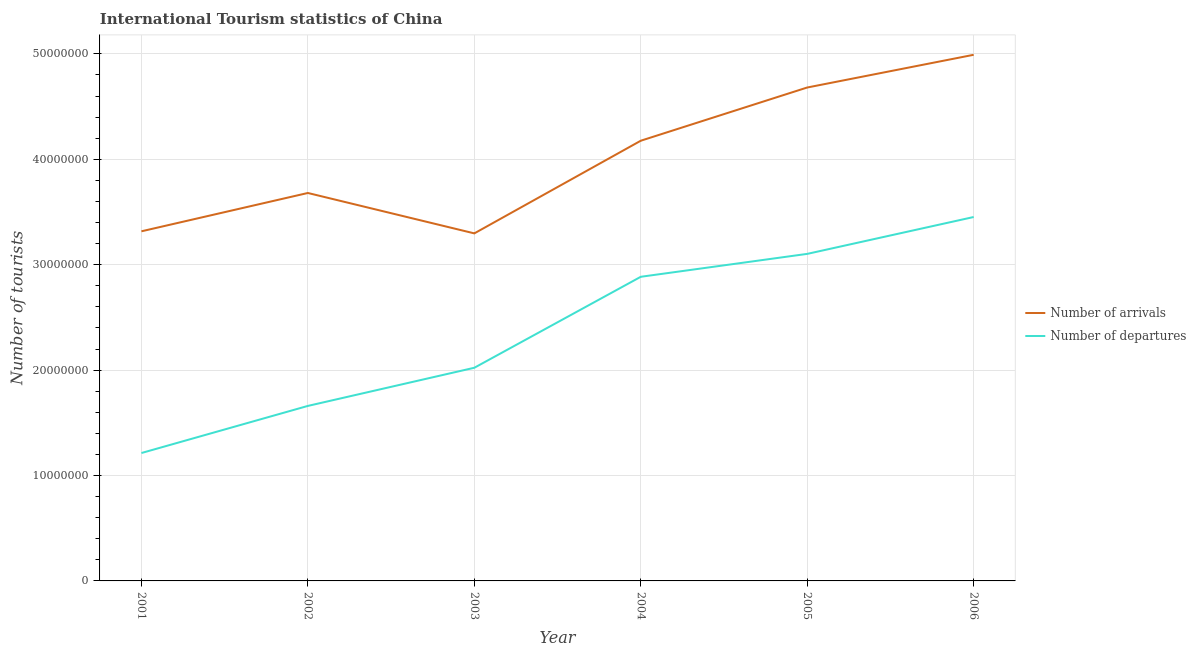How many different coloured lines are there?
Offer a very short reply. 2. Is the number of lines equal to the number of legend labels?
Your answer should be compact. Yes. What is the number of tourist departures in 2004?
Keep it short and to the point. 2.89e+07. Across all years, what is the maximum number of tourist departures?
Offer a terse response. 3.45e+07. Across all years, what is the minimum number of tourist arrivals?
Give a very brief answer. 3.30e+07. In which year was the number of tourist departures maximum?
Provide a succinct answer. 2006. What is the total number of tourist arrivals in the graph?
Keep it short and to the point. 2.41e+08. What is the difference between the number of tourist arrivals in 2004 and that in 2005?
Give a very brief answer. -5.05e+06. What is the difference between the number of tourist departures in 2003 and the number of tourist arrivals in 2004?
Your response must be concise. -2.15e+07. What is the average number of tourist arrivals per year?
Offer a very short reply. 4.02e+07. In the year 2005, what is the difference between the number of tourist departures and number of tourist arrivals?
Your response must be concise. -1.58e+07. In how many years, is the number of tourist arrivals greater than 46000000?
Give a very brief answer. 2. What is the ratio of the number of tourist departures in 2002 to that in 2006?
Your answer should be very brief. 0.48. Is the number of tourist departures in 2002 less than that in 2003?
Ensure brevity in your answer.  Yes. Is the difference between the number of tourist departures in 2003 and 2006 greater than the difference between the number of tourist arrivals in 2003 and 2006?
Make the answer very short. Yes. What is the difference between the highest and the second highest number of tourist departures?
Ensure brevity in your answer.  3.50e+06. What is the difference between the highest and the lowest number of tourist arrivals?
Your response must be concise. 1.69e+07. In how many years, is the number of tourist departures greater than the average number of tourist departures taken over all years?
Make the answer very short. 3. Is the sum of the number of tourist departures in 2002 and 2004 greater than the maximum number of tourist arrivals across all years?
Make the answer very short. No. Is the number of tourist arrivals strictly greater than the number of tourist departures over the years?
Your answer should be compact. Yes. What is the difference between two consecutive major ticks on the Y-axis?
Your answer should be very brief. 1.00e+07. Are the values on the major ticks of Y-axis written in scientific E-notation?
Your response must be concise. No. Does the graph contain grids?
Offer a very short reply. Yes. What is the title of the graph?
Provide a short and direct response. International Tourism statistics of China. Does "Private funds" appear as one of the legend labels in the graph?
Provide a succinct answer. No. What is the label or title of the Y-axis?
Offer a very short reply. Number of tourists. What is the Number of tourists of Number of arrivals in 2001?
Provide a succinct answer. 3.32e+07. What is the Number of tourists of Number of departures in 2001?
Offer a very short reply. 1.21e+07. What is the Number of tourists in Number of arrivals in 2002?
Your response must be concise. 3.68e+07. What is the Number of tourists in Number of departures in 2002?
Offer a very short reply. 1.66e+07. What is the Number of tourists of Number of arrivals in 2003?
Keep it short and to the point. 3.30e+07. What is the Number of tourists in Number of departures in 2003?
Offer a very short reply. 2.02e+07. What is the Number of tourists of Number of arrivals in 2004?
Your answer should be compact. 4.18e+07. What is the Number of tourists of Number of departures in 2004?
Offer a very short reply. 2.89e+07. What is the Number of tourists of Number of arrivals in 2005?
Offer a terse response. 4.68e+07. What is the Number of tourists of Number of departures in 2005?
Your answer should be very brief. 3.10e+07. What is the Number of tourists of Number of arrivals in 2006?
Your response must be concise. 4.99e+07. What is the Number of tourists of Number of departures in 2006?
Your response must be concise. 3.45e+07. Across all years, what is the maximum Number of tourists in Number of arrivals?
Offer a very short reply. 4.99e+07. Across all years, what is the maximum Number of tourists of Number of departures?
Your answer should be very brief. 3.45e+07. Across all years, what is the minimum Number of tourists of Number of arrivals?
Give a very brief answer. 3.30e+07. Across all years, what is the minimum Number of tourists of Number of departures?
Your answer should be compact. 1.21e+07. What is the total Number of tourists in Number of arrivals in the graph?
Your response must be concise. 2.41e+08. What is the total Number of tourists of Number of departures in the graph?
Offer a terse response. 1.43e+08. What is the difference between the Number of tourists of Number of arrivals in 2001 and that in 2002?
Provide a succinct answer. -3.64e+06. What is the difference between the Number of tourists in Number of departures in 2001 and that in 2002?
Your response must be concise. -4.47e+06. What is the difference between the Number of tourists in Number of arrivals in 2001 and that in 2003?
Keep it short and to the point. 1.97e+05. What is the difference between the Number of tourists of Number of departures in 2001 and that in 2003?
Your response must be concise. -8.09e+06. What is the difference between the Number of tourists of Number of arrivals in 2001 and that in 2004?
Keep it short and to the point. -8.59e+06. What is the difference between the Number of tourists of Number of departures in 2001 and that in 2004?
Your answer should be very brief. -1.67e+07. What is the difference between the Number of tourists in Number of arrivals in 2001 and that in 2005?
Offer a very short reply. -1.36e+07. What is the difference between the Number of tourists in Number of departures in 2001 and that in 2005?
Your answer should be very brief. -1.89e+07. What is the difference between the Number of tourists in Number of arrivals in 2001 and that in 2006?
Your answer should be very brief. -1.67e+07. What is the difference between the Number of tourists of Number of departures in 2001 and that in 2006?
Ensure brevity in your answer.  -2.24e+07. What is the difference between the Number of tourists in Number of arrivals in 2002 and that in 2003?
Your answer should be very brief. 3.83e+06. What is the difference between the Number of tourists in Number of departures in 2002 and that in 2003?
Your response must be concise. -3.62e+06. What is the difference between the Number of tourists in Number of arrivals in 2002 and that in 2004?
Offer a very short reply. -4.96e+06. What is the difference between the Number of tourists in Number of departures in 2002 and that in 2004?
Ensure brevity in your answer.  -1.23e+07. What is the difference between the Number of tourists in Number of arrivals in 2002 and that in 2005?
Give a very brief answer. -1.00e+07. What is the difference between the Number of tourists in Number of departures in 2002 and that in 2005?
Your answer should be very brief. -1.44e+07. What is the difference between the Number of tourists in Number of arrivals in 2002 and that in 2006?
Offer a very short reply. -1.31e+07. What is the difference between the Number of tourists of Number of departures in 2002 and that in 2006?
Provide a succinct answer. -1.79e+07. What is the difference between the Number of tourists in Number of arrivals in 2003 and that in 2004?
Your response must be concise. -8.79e+06. What is the difference between the Number of tourists of Number of departures in 2003 and that in 2004?
Offer a terse response. -8.63e+06. What is the difference between the Number of tourists in Number of arrivals in 2003 and that in 2005?
Your answer should be very brief. -1.38e+07. What is the difference between the Number of tourists in Number of departures in 2003 and that in 2005?
Keep it short and to the point. -1.08e+07. What is the difference between the Number of tourists of Number of arrivals in 2003 and that in 2006?
Your answer should be compact. -1.69e+07. What is the difference between the Number of tourists in Number of departures in 2003 and that in 2006?
Your response must be concise. -1.43e+07. What is the difference between the Number of tourists in Number of arrivals in 2004 and that in 2005?
Offer a terse response. -5.05e+06. What is the difference between the Number of tourists in Number of departures in 2004 and that in 2005?
Your answer should be compact. -2.17e+06. What is the difference between the Number of tourists in Number of arrivals in 2004 and that in 2006?
Ensure brevity in your answer.  -8.15e+06. What is the difference between the Number of tourists of Number of departures in 2004 and that in 2006?
Ensure brevity in your answer.  -5.67e+06. What is the difference between the Number of tourists in Number of arrivals in 2005 and that in 2006?
Your answer should be very brief. -3.10e+06. What is the difference between the Number of tourists of Number of departures in 2005 and that in 2006?
Your answer should be compact. -3.50e+06. What is the difference between the Number of tourists of Number of arrivals in 2001 and the Number of tourists of Number of departures in 2002?
Keep it short and to the point. 1.66e+07. What is the difference between the Number of tourists of Number of arrivals in 2001 and the Number of tourists of Number of departures in 2003?
Offer a very short reply. 1.29e+07. What is the difference between the Number of tourists in Number of arrivals in 2001 and the Number of tourists in Number of departures in 2004?
Offer a terse response. 4.31e+06. What is the difference between the Number of tourists of Number of arrivals in 2001 and the Number of tourists of Number of departures in 2005?
Your answer should be compact. 2.14e+06. What is the difference between the Number of tourists in Number of arrivals in 2001 and the Number of tourists in Number of departures in 2006?
Provide a succinct answer. -1.36e+06. What is the difference between the Number of tourists of Number of arrivals in 2002 and the Number of tourists of Number of departures in 2003?
Give a very brief answer. 1.66e+07. What is the difference between the Number of tourists of Number of arrivals in 2002 and the Number of tourists of Number of departures in 2004?
Provide a succinct answer. 7.95e+06. What is the difference between the Number of tourists of Number of arrivals in 2002 and the Number of tourists of Number of departures in 2005?
Keep it short and to the point. 5.78e+06. What is the difference between the Number of tourists in Number of arrivals in 2002 and the Number of tourists in Number of departures in 2006?
Your answer should be very brief. 2.28e+06. What is the difference between the Number of tourists in Number of arrivals in 2003 and the Number of tourists in Number of departures in 2004?
Give a very brief answer. 4.12e+06. What is the difference between the Number of tourists of Number of arrivals in 2003 and the Number of tourists of Number of departures in 2005?
Your answer should be very brief. 1.94e+06. What is the difference between the Number of tourists of Number of arrivals in 2003 and the Number of tourists of Number of departures in 2006?
Your response must be concise. -1.55e+06. What is the difference between the Number of tourists of Number of arrivals in 2004 and the Number of tourists of Number of departures in 2005?
Offer a terse response. 1.07e+07. What is the difference between the Number of tourists of Number of arrivals in 2004 and the Number of tourists of Number of departures in 2006?
Provide a succinct answer. 7.24e+06. What is the difference between the Number of tourists in Number of arrivals in 2005 and the Number of tourists in Number of departures in 2006?
Provide a succinct answer. 1.23e+07. What is the average Number of tourists in Number of arrivals per year?
Your answer should be very brief. 4.02e+07. What is the average Number of tourists in Number of departures per year?
Offer a terse response. 2.39e+07. In the year 2001, what is the difference between the Number of tourists of Number of arrivals and Number of tourists of Number of departures?
Give a very brief answer. 2.10e+07. In the year 2002, what is the difference between the Number of tourists in Number of arrivals and Number of tourists in Number of departures?
Your answer should be very brief. 2.02e+07. In the year 2003, what is the difference between the Number of tourists in Number of arrivals and Number of tourists in Number of departures?
Offer a terse response. 1.27e+07. In the year 2004, what is the difference between the Number of tourists of Number of arrivals and Number of tourists of Number of departures?
Keep it short and to the point. 1.29e+07. In the year 2005, what is the difference between the Number of tourists in Number of arrivals and Number of tourists in Number of departures?
Keep it short and to the point. 1.58e+07. In the year 2006, what is the difference between the Number of tourists of Number of arrivals and Number of tourists of Number of departures?
Your answer should be very brief. 1.54e+07. What is the ratio of the Number of tourists of Number of arrivals in 2001 to that in 2002?
Provide a short and direct response. 0.9. What is the ratio of the Number of tourists of Number of departures in 2001 to that in 2002?
Offer a terse response. 0.73. What is the ratio of the Number of tourists of Number of departures in 2001 to that in 2003?
Offer a very short reply. 0.6. What is the ratio of the Number of tourists in Number of arrivals in 2001 to that in 2004?
Give a very brief answer. 0.79. What is the ratio of the Number of tourists of Number of departures in 2001 to that in 2004?
Give a very brief answer. 0.42. What is the ratio of the Number of tourists of Number of arrivals in 2001 to that in 2005?
Offer a terse response. 0.71. What is the ratio of the Number of tourists of Number of departures in 2001 to that in 2005?
Offer a terse response. 0.39. What is the ratio of the Number of tourists in Number of arrivals in 2001 to that in 2006?
Provide a short and direct response. 0.66. What is the ratio of the Number of tourists in Number of departures in 2001 to that in 2006?
Keep it short and to the point. 0.35. What is the ratio of the Number of tourists in Number of arrivals in 2002 to that in 2003?
Offer a terse response. 1.12. What is the ratio of the Number of tourists of Number of departures in 2002 to that in 2003?
Ensure brevity in your answer.  0.82. What is the ratio of the Number of tourists of Number of arrivals in 2002 to that in 2004?
Offer a very short reply. 0.88. What is the ratio of the Number of tourists in Number of departures in 2002 to that in 2004?
Offer a terse response. 0.58. What is the ratio of the Number of tourists in Number of arrivals in 2002 to that in 2005?
Your answer should be very brief. 0.79. What is the ratio of the Number of tourists in Number of departures in 2002 to that in 2005?
Your answer should be very brief. 0.54. What is the ratio of the Number of tourists of Number of arrivals in 2002 to that in 2006?
Ensure brevity in your answer.  0.74. What is the ratio of the Number of tourists of Number of departures in 2002 to that in 2006?
Your response must be concise. 0.48. What is the ratio of the Number of tourists in Number of arrivals in 2003 to that in 2004?
Make the answer very short. 0.79. What is the ratio of the Number of tourists of Number of departures in 2003 to that in 2004?
Give a very brief answer. 0.7. What is the ratio of the Number of tourists of Number of arrivals in 2003 to that in 2005?
Make the answer very short. 0.7. What is the ratio of the Number of tourists of Number of departures in 2003 to that in 2005?
Ensure brevity in your answer.  0.65. What is the ratio of the Number of tourists in Number of arrivals in 2003 to that in 2006?
Provide a short and direct response. 0.66. What is the ratio of the Number of tourists in Number of departures in 2003 to that in 2006?
Give a very brief answer. 0.59. What is the ratio of the Number of tourists in Number of arrivals in 2004 to that in 2005?
Offer a terse response. 0.89. What is the ratio of the Number of tourists of Number of departures in 2004 to that in 2005?
Give a very brief answer. 0.93. What is the ratio of the Number of tourists of Number of arrivals in 2004 to that in 2006?
Your answer should be compact. 0.84. What is the ratio of the Number of tourists in Number of departures in 2004 to that in 2006?
Your answer should be very brief. 0.84. What is the ratio of the Number of tourists in Number of arrivals in 2005 to that in 2006?
Your answer should be compact. 0.94. What is the ratio of the Number of tourists of Number of departures in 2005 to that in 2006?
Make the answer very short. 0.9. What is the difference between the highest and the second highest Number of tourists of Number of arrivals?
Give a very brief answer. 3.10e+06. What is the difference between the highest and the second highest Number of tourists of Number of departures?
Keep it short and to the point. 3.50e+06. What is the difference between the highest and the lowest Number of tourists in Number of arrivals?
Make the answer very short. 1.69e+07. What is the difference between the highest and the lowest Number of tourists in Number of departures?
Your response must be concise. 2.24e+07. 